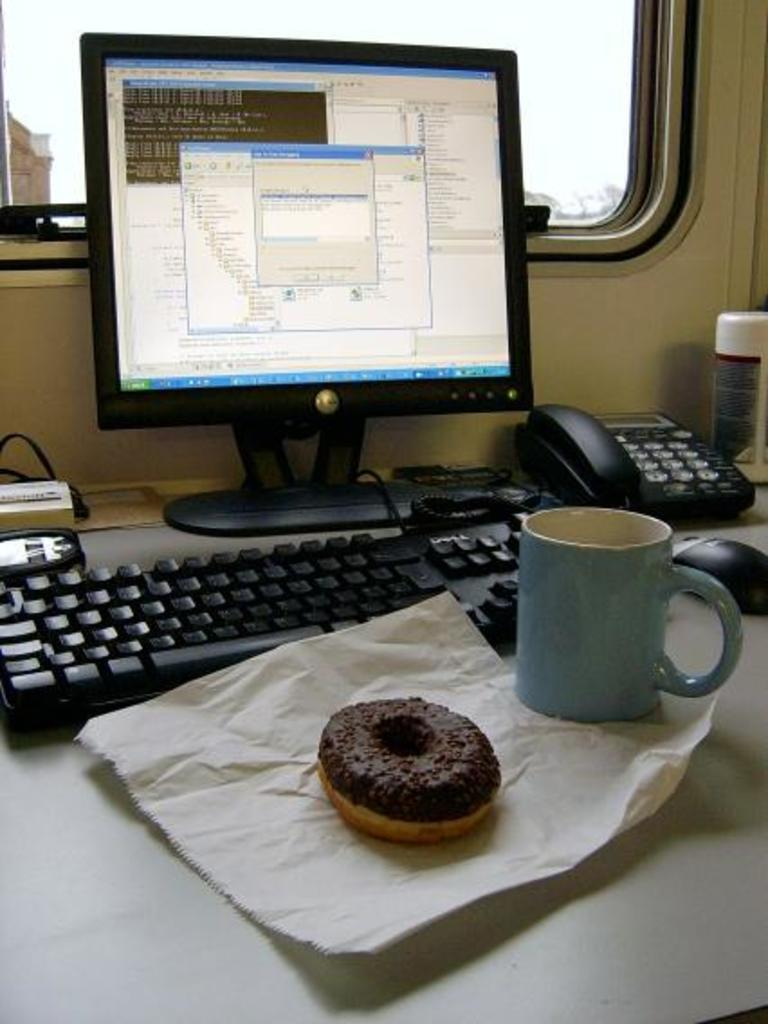What type of food is visible in the image? There is a doughnut in the image. What is the other object on the table besides the doughnut? There is a cup in the image. What system is present in the image? There is a system in the image, but the specific type is not mentioned. What communication device is visible in the image? There is a telephone in the image. What beverage container is present in the image? There is a bottle in the image. Where are all these objects located? All of these objects are on a table. What can be seen in the background of the image? There is a window in the background of the image, and the sky is visible through it. What type of stream is visible in the image? There is no stream present in the image. What type of basin is used for washing hands in the image? There is no basin present in the image. 